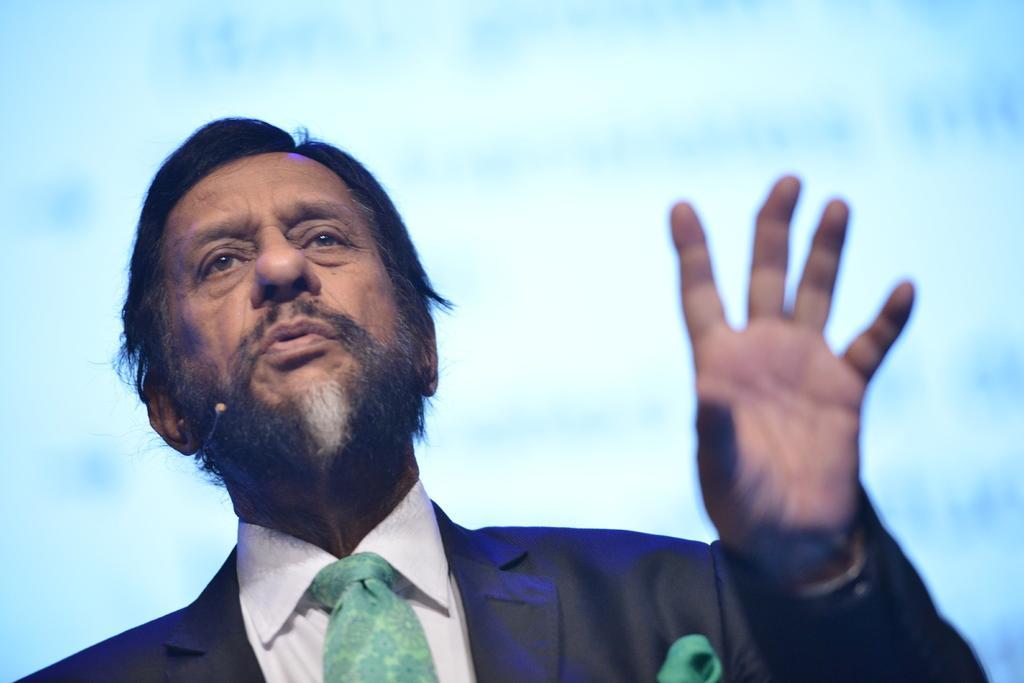How would you summarize this image in a sentence or two? In this picture I can see a person wearing a black color suit. 